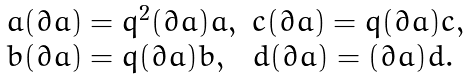Convert formula to latex. <formula><loc_0><loc_0><loc_500><loc_500>\begin{array} { l l } a ( \partial a ) = q ^ { 2 } ( \partial a ) a , & c ( \partial a ) = q ( \partial a ) c , \\ b ( \partial a ) = q ( \partial a ) b , & d ( \partial a ) = ( \partial a ) d . \end{array}</formula> 